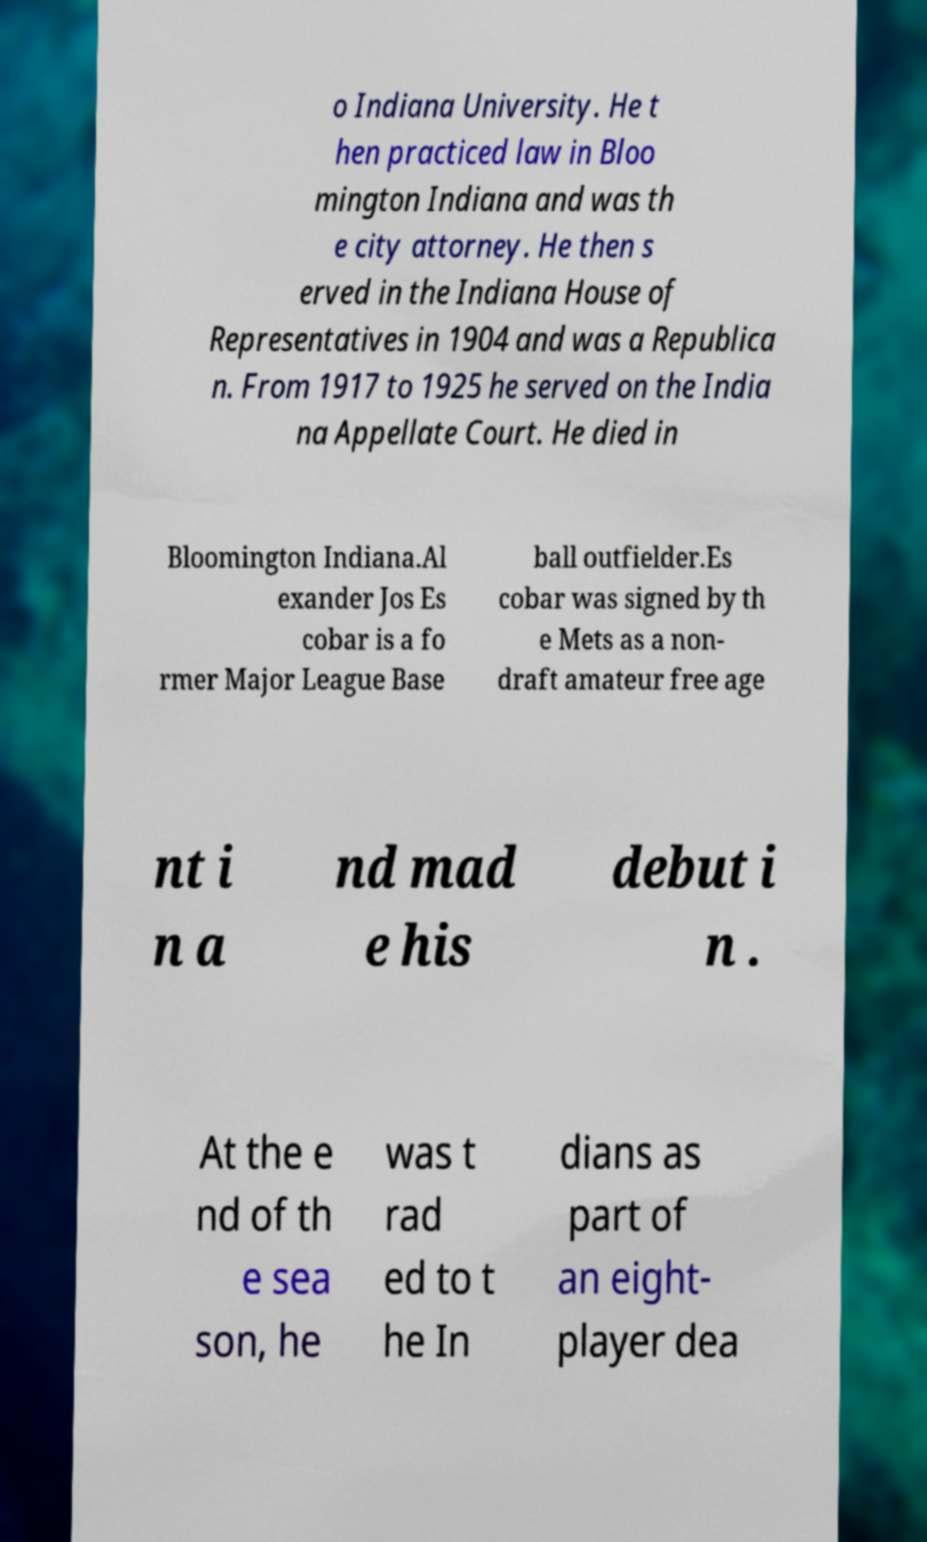Can you read and provide the text displayed in the image?This photo seems to have some interesting text. Can you extract and type it out for me? o Indiana University. He t hen practiced law in Bloo mington Indiana and was th e city attorney. He then s erved in the Indiana House of Representatives in 1904 and was a Republica n. From 1917 to 1925 he served on the India na Appellate Court. He died in Bloomington Indiana.Al exander Jos Es cobar is a fo rmer Major League Base ball outfielder.Es cobar was signed by th e Mets as a non- draft amateur free age nt i n a nd mad e his debut i n . At the e nd of th e sea son, he was t rad ed to t he In dians as part of an eight- player dea 